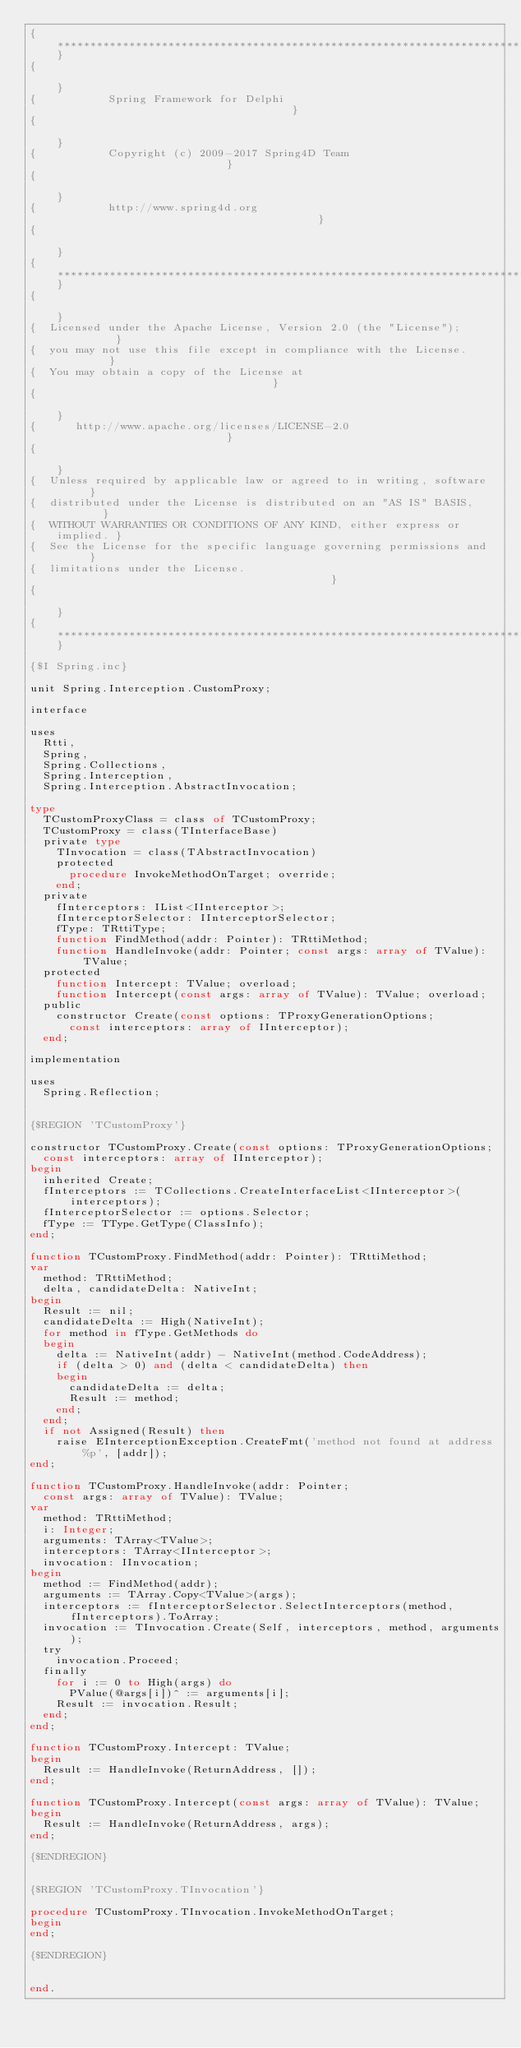Convert code to text. <code><loc_0><loc_0><loc_500><loc_500><_Pascal_>{***************************************************************************}
{                                                                           }
{           Spring Framework for Delphi                                     }
{                                                                           }
{           Copyright (c) 2009-2017 Spring4D Team                           }
{                                                                           }
{           http://www.spring4d.org                                         }
{                                                                           }
{***************************************************************************}
{                                                                           }
{  Licensed under the Apache License, Version 2.0 (the "License");          }
{  you may not use this file except in compliance with the License.         }
{  You may obtain a copy of the License at                                  }
{                                                                           }
{      http://www.apache.org/licenses/LICENSE-2.0                           }
{                                                                           }
{  Unless required by applicable law or agreed to in writing, software      }
{  distributed under the License is distributed on an "AS IS" BASIS,        }
{  WITHOUT WARRANTIES OR CONDITIONS OF ANY KIND, either express or implied. }
{  See the License for the specific language governing permissions and      }
{  limitations under the License.                                           }
{                                                                           }
{***************************************************************************}

{$I Spring.inc}

unit Spring.Interception.CustomProxy;

interface

uses
  Rtti,
  Spring,
  Spring.Collections,
  Spring.Interception,
  Spring.Interception.AbstractInvocation;

type
  TCustomProxyClass = class of TCustomProxy;
  TCustomProxy = class(TInterfaceBase)
  private type
    TInvocation = class(TAbstractInvocation)
    protected
      procedure InvokeMethodOnTarget; override;
    end;
  private
    fInterceptors: IList<IInterceptor>;
    fInterceptorSelector: IInterceptorSelector;
    fType: TRttiType;
    function FindMethod(addr: Pointer): TRttiMethod;
    function HandleInvoke(addr: Pointer; const args: array of TValue): TValue;
  protected
    function Intercept: TValue; overload;
    function Intercept(const args: array of TValue): TValue; overload;
  public
    constructor Create(const options: TProxyGenerationOptions;
      const interceptors: array of IInterceptor);
  end;

implementation

uses
  Spring.Reflection;


{$REGION 'TCustomProxy'}

constructor TCustomProxy.Create(const options: TProxyGenerationOptions;
  const interceptors: array of IInterceptor);
begin
  inherited Create;
  fInterceptors := TCollections.CreateInterfaceList<IInterceptor>(interceptors);
  fInterceptorSelector := options.Selector;
  fType := TType.GetType(ClassInfo);
end;

function TCustomProxy.FindMethod(addr: Pointer): TRttiMethod;
var
  method: TRttiMethod;
  delta, candidateDelta: NativeInt;
begin
  Result := nil;
  candidateDelta := High(NativeInt);
  for method in fType.GetMethods do
  begin
    delta := NativeInt(addr) - NativeInt(method.CodeAddress);
    if (delta > 0) and (delta < candidateDelta) then
    begin
      candidateDelta := delta;
      Result := method;
    end;
  end;
  if not Assigned(Result) then
    raise EInterceptionException.CreateFmt('method not found at address %p', [addr]);
end;

function TCustomProxy.HandleInvoke(addr: Pointer;
  const args: array of TValue): TValue;
var
  method: TRttiMethod;
  i: Integer;
  arguments: TArray<TValue>;
  interceptors: TArray<IInterceptor>;
  invocation: IInvocation;
begin
  method := FindMethod(addr);
  arguments := TArray.Copy<TValue>(args);
  interceptors := fInterceptorSelector.SelectInterceptors(method, fInterceptors).ToArray;
  invocation := TInvocation.Create(Self, interceptors, method, arguments);
  try
    invocation.Proceed;
  finally
    for i := 0 to High(args) do
      PValue(@args[i])^ := arguments[i];
    Result := invocation.Result;
  end;
end;

function TCustomProxy.Intercept: TValue;
begin
  Result := HandleInvoke(ReturnAddress, []);
end;

function TCustomProxy.Intercept(const args: array of TValue): TValue;
begin
  Result := HandleInvoke(ReturnAddress, args);
end;

{$ENDREGION}


{$REGION 'TCustomProxy.TInvocation'}

procedure TCustomProxy.TInvocation.InvokeMethodOnTarget;
begin
end;

{$ENDREGION}


end.
</code> 